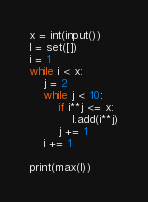Convert code to text. <code><loc_0><loc_0><loc_500><loc_500><_Python_>x = int(input())
l = set([])
i = 1
while i < x:
    j = 2
    while j < 10:
        if i**j <= x:
            l.add(i**j)
        j += 1
    i += 1

print(max(l))</code> 